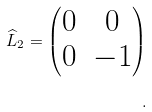Convert formula to latex. <formula><loc_0><loc_0><loc_500><loc_500>\widehat { L } _ { 2 } = \left ( \begin{matrix} 0 & 0 \\ 0 & - 1 \\ \end{matrix} \right ) \\ .</formula> 